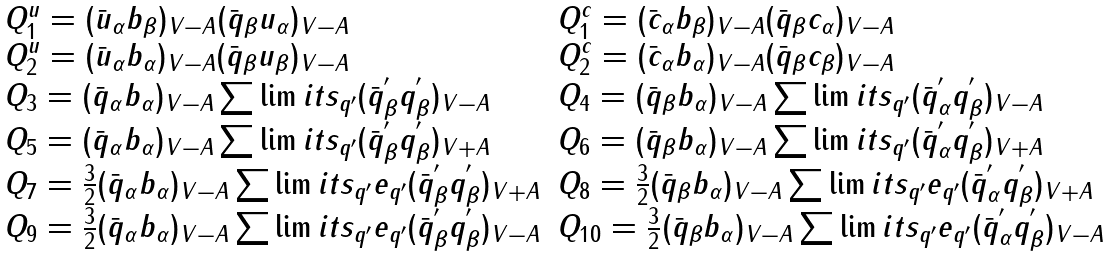Convert formula to latex. <formula><loc_0><loc_0><loc_500><loc_500>\begin{array} { l } \begin{array} { l l } Q ^ { u } _ { 1 } = ( \bar { u } _ { \alpha } b _ { \beta } ) _ { V - A } ( \bar { q } _ { \beta } u _ { \alpha } ) _ { V - A } & Q ^ { c } _ { 1 } = ( \bar { c } _ { \alpha } b _ { \beta } ) _ { V - A } ( \bar { q } _ { \beta } c _ { \alpha } ) _ { V - A } \\ Q ^ { u } _ { 2 } = ( \bar { u } _ { \alpha } b _ { \alpha } ) _ { V - A } ( \bar { q } _ { \beta } u _ { \beta } ) _ { V - A } & Q ^ { c } _ { 2 } = ( \bar { c } _ { \alpha } b _ { \alpha } ) _ { V - A } ( \bar { q } _ { \beta } c _ { \beta } ) _ { V - A } \\ Q _ { 3 } = ( \bar { q } _ { \alpha } b _ { \alpha } ) _ { V - A } \sum \lim i t s _ { q ^ { \prime } } ( \bar { q } ^ { ^ { \prime } } _ { \beta } q ^ { ^ { \prime } } _ { \beta } ) _ { V - A } & Q _ { 4 } = ( \bar { q } _ { \beta } b _ { \alpha } ) _ { V - A } \sum \lim i t s _ { q ^ { \prime } } ( \bar { q } ^ { ^ { \prime } } _ { \alpha } q ^ { ^ { \prime } } _ { \beta } ) _ { V - A } \\ Q _ { 5 } = ( \bar { q } _ { \alpha } b _ { \alpha } ) _ { V - A } \sum \lim i t s _ { q ^ { \prime } } ( \bar { q } ^ { ^ { \prime } } _ { \beta } q ^ { ^ { \prime } } _ { \beta } ) _ { V + A } & Q _ { 6 } = ( \bar { q } _ { \beta } b _ { \alpha } ) _ { V - A } \sum \lim i t s _ { q ^ { \prime } } ( \bar { q } ^ { ^ { \prime } } _ { \alpha } q ^ { ^ { \prime } } _ { \beta } ) _ { V + A } \\ Q _ { 7 } = \frac { 3 } { 2 } ( \bar { q } _ { \alpha } b _ { \alpha } ) _ { V - A } \sum \lim i t s _ { q ^ { \prime } } e _ { q ^ { \prime } } ( \bar { q } ^ { ^ { \prime } } _ { \beta } q ^ { ^ { \prime } } _ { \beta } ) _ { V + A } & Q _ { 8 } = \frac { 3 } { 2 } ( \bar { q } _ { \beta } b _ { \alpha } ) _ { V - A } \sum \lim i t s _ { q ^ { \prime } } e _ { q ^ { \prime } } ( \bar { q } ^ { ^ { \prime } } _ { \alpha } q ^ { ^ { \prime } } _ { \beta } ) _ { V + A } \\ Q _ { 9 } = \frac { 3 } { 2 } ( \bar { q } _ { \alpha } b _ { \alpha } ) _ { V - A } \sum \lim i t s _ { q ^ { \prime } } e _ { q ^ { \prime } } ( \bar { q } ^ { ^ { \prime } } _ { \beta } q ^ { ^ { \prime } } _ { \beta } ) _ { V - A } & Q _ { 1 0 } = \frac { 3 } { 2 } ( \bar { q } _ { \beta } b _ { \alpha } ) _ { V - A } \sum \lim i t s _ { q ^ { \prime } } e _ { q ^ { \prime } } ( \bar { q } ^ { ^ { \prime } } _ { \alpha } q ^ { ^ { \prime } } _ { \beta } ) _ { V - A } \\ \end{array} \\ \end{array}</formula> 